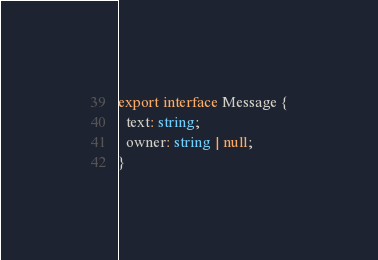<code> <loc_0><loc_0><loc_500><loc_500><_TypeScript_>export interface Message {
  text: string;
  owner: string | null;
}
</code> 